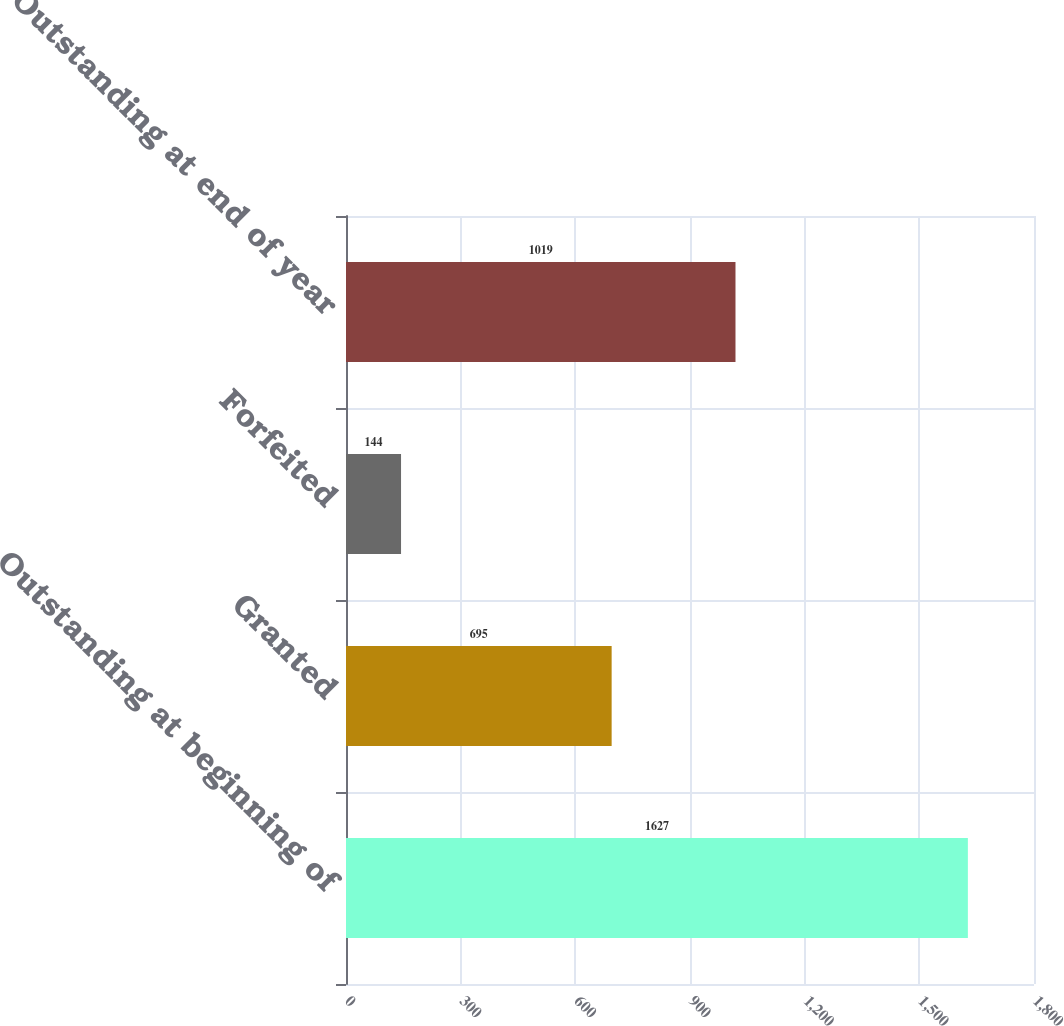Convert chart. <chart><loc_0><loc_0><loc_500><loc_500><bar_chart><fcel>Outstanding at beginning of<fcel>Granted<fcel>Forfeited<fcel>Outstanding at end of year<nl><fcel>1627<fcel>695<fcel>144<fcel>1019<nl></chart> 